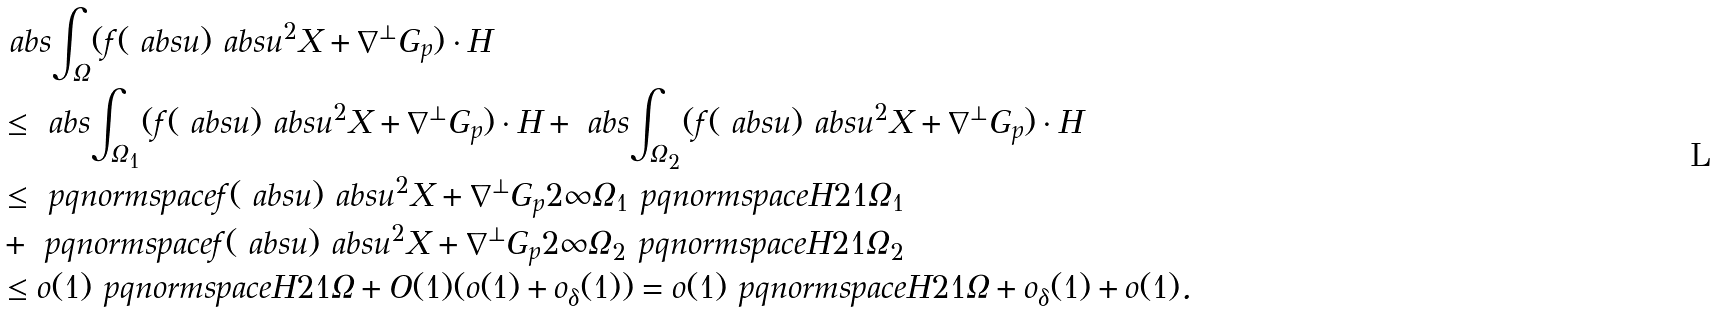Convert formula to latex. <formula><loc_0><loc_0><loc_500><loc_500>& \ a b s { \int _ { \Omega } ( f ( \ a b s { u } ) \ a b s { u } ^ { 2 } X + \nabla ^ { \bot } G _ { p } ) \cdot H } \\ & \leq \ a b s { \int _ { \Omega _ { 1 } } ( f ( \ a b s { u } ) \ a b s { u } ^ { 2 } X + \nabla ^ { \bot } G _ { p } ) \cdot H } + \ a b s { \int _ { \Omega _ { 2 } } ( f ( \ a b s { u } ) \ a b s { u } ^ { 2 } X + \nabla ^ { \bot } G _ { p } ) \cdot H } \\ & \leq \ p q n o r m s p a c e { f ( \ a b s { u } ) \ a b s { u } ^ { 2 } X + \nabla ^ { \bot } G _ { p } } { 2 } { \infty } { \Omega _ { 1 } } \ p q n o r m s p a c e { H } { 2 } { 1 } { \Omega _ { 1 } } \\ & + \ p q n o r m s p a c e { f ( \ a b s { u } ) \ a b s { u } ^ { 2 } X + \nabla ^ { \bot } G _ { p } } { 2 } { \infty } { \Omega _ { 2 } } \ p q n o r m s p a c e { H } { 2 } { 1 } { \Omega _ { 2 } } \\ & \leq o ( 1 ) \ p q n o r m s p a c e { H } { 2 } { 1 } { \Omega } + O ( 1 ) ( o ( 1 ) + o _ { \delta } ( 1 ) ) = o ( 1 ) \ p q n o r m s p a c e { H } { 2 } { 1 } { \Omega } + o _ { \delta } ( 1 ) + o ( 1 ) .</formula> 